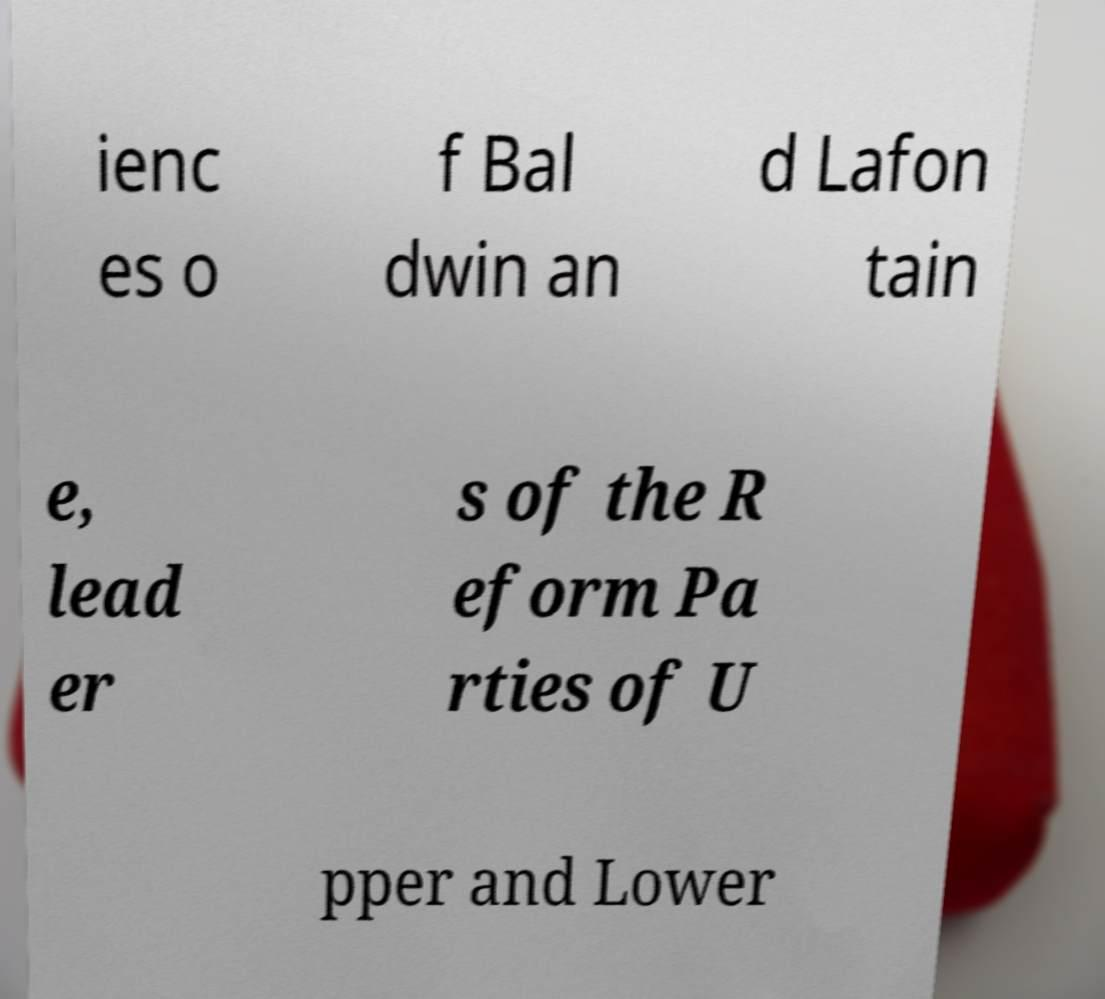Please read and relay the text visible in this image. What does it say? ienc es o f Bal dwin an d Lafon tain e, lead er s of the R eform Pa rties of U pper and Lower 